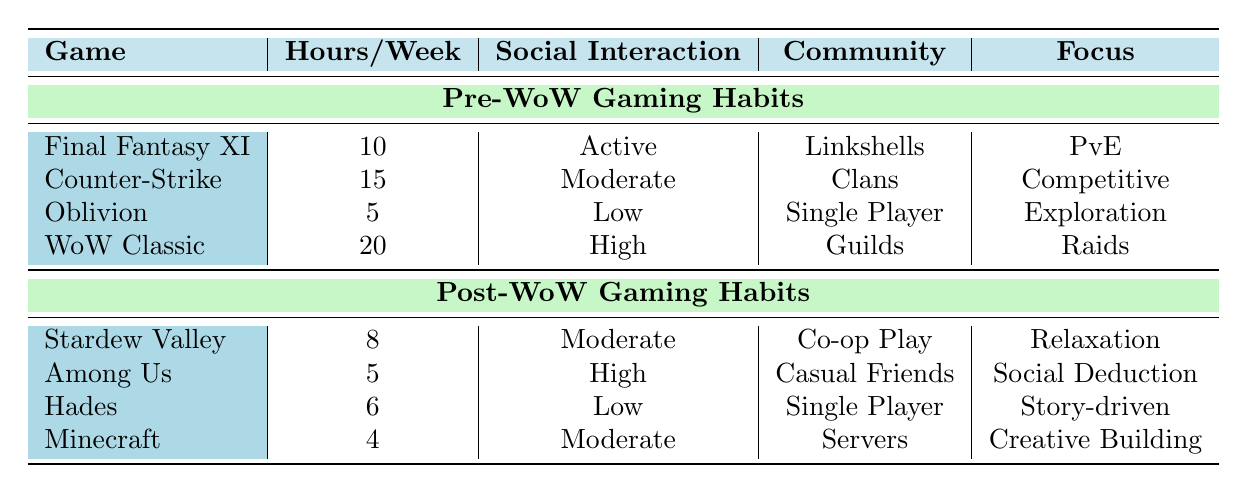What was the game played the most before World of Warcraft? Looking at the table, "World of Warcraft Classic" has the highest hours per week at 20, making it the most played game before World of Warcraft among the listed options.
Answer: World of Warcraft Classic How many hours were spent gaming per week on average before World of Warcraft? To find the average, add up the hours (10 + 15 + 5 + 20 = 50) and divide by the number of games (4). So, the average is 50/4 = 12.5 hours per week.
Answer: 12.5 Is the social interaction level while playing "Among Us" rated as high after World of Warcraft? According to the table, the social interaction for "Among Us" is classified as high, confirming the statement to be true.
Answer: Yes Which game had the least amount of hours played per week after World of Warcraft? The game with the least hours played after World of Warcraft is "Minecraft," with 4 hours per week.
Answer: Minecraft Did the gaming focus shift from competitive play to relaxation after World of Warcraft? Evaluating the focuses for post-WoW games, there is a notable focus on relaxation with "Stardew Valley." In contrast, the pre-WoW focus included competitive gaming ("Counter-Strike"). Hence, it suggests a shift from competitive play to relaxation.
Answer: Yes What is the total amount of hours spent weekly on gaming before World of Warcraft? The total is calculated by summing the individual hours: 10 (Final Fantasy XI) + 15 (Counter-Strike) + 5 (Oblivion) + 20 (WoW Classic) = 50 hours per week.
Answer: 50 Was there any game focused on exploration after World of Warcraft? In the post-WoW section, none of the listed games specifies exploration as their focus. Therefore, the statement is false.
Answer: No How many games had high social interaction before World of Warcraft? Reviewing the pre-WoW habits, "World of Warcraft Classic" has high social interaction, which is the only game with this classification, meaning there is only one such game.
Answer: 1 What was the average focus type change from pre to post World of Warcraft? Pre-WoW focused on PvE, competitive, exploration, and raids, while post-WoW shifted to relaxation, social deduction, story-driven, and creative building. This indicates a mix, but the focus has generally become more relaxing or casual post-WoW compared to the intensity of raids and competition before.
Answer: More relaxing or casual 